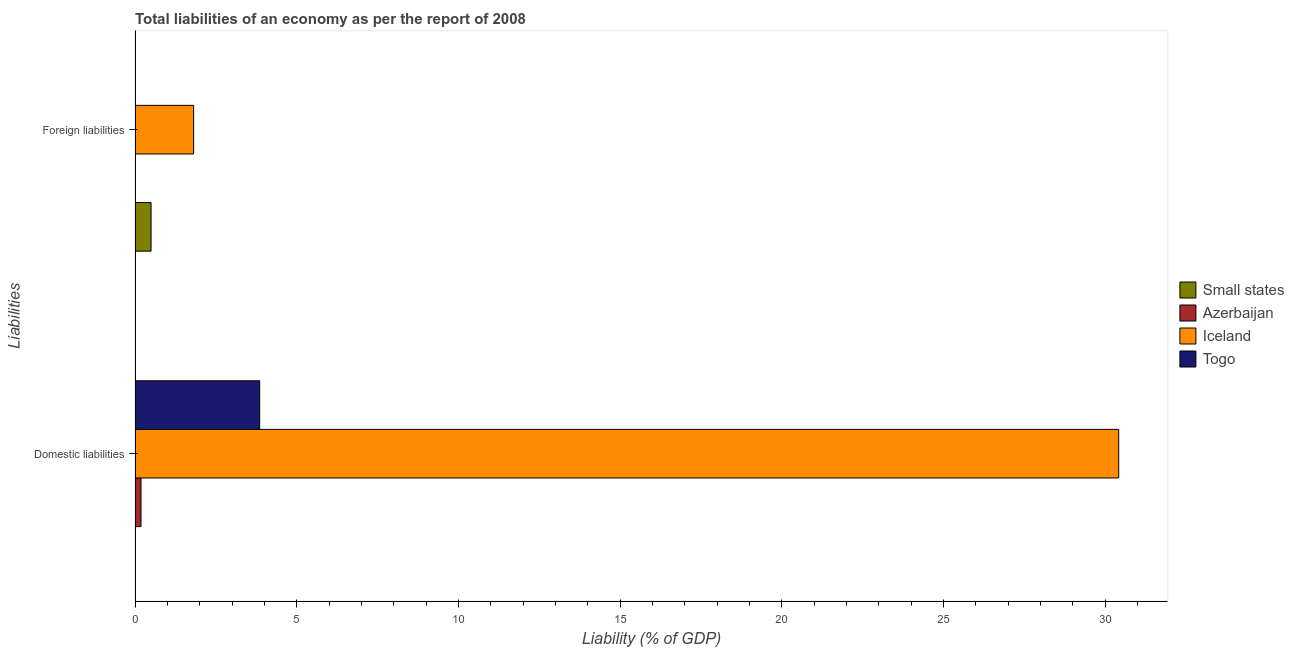How many bars are there on the 1st tick from the top?
Provide a short and direct response. 2. What is the label of the 1st group of bars from the top?
Give a very brief answer. Foreign liabilities. Across all countries, what is the maximum incurrence of foreign liabilities?
Provide a short and direct response. 1.81. In which country was the incurrence of foreign liabilities maximum?
Ensure brevity in your answer.  Iceland. What is the total incurrence of domestic liabilities in the graph?
Your answer should be very brief. 34.45. What is the difference between the incurrence of domestic liabilities in Iceland and that in Togo?
Your answer should be very brief. 26.56. What is the difference between the incurrence of foreign liabilities in Azerbaijan and the incurrence of domestic liabilities in Togo?
Provide a succinct answer. -3.85. What is the average incurrence of foreign liabilities per country?
Offer a very short reply. 0.58. What is the difference between the incurrence of foreign liabilities and incurrence of domestic liabilities in Iceland?
Your response must be concise. -28.6. In how many countries, is the incurrence of foreign liabilities greater than 22 %?
Provide a succinct answer. 0. What is the ratio of the incurrence of foreign liabilities in Iceland to that in Small states?
Keep it short and to the point. 3.66. In how many countries, is the incurrence of foreign liabilities greater than the average incurrence of foreign liabilities taken over all countries?
Make the answer very short. 1. How many bars are there?
Provide a succinct answer. 5. Are all the bars in the graph horizontal?
Your response must be concise. Yes. Does the graph contain grids?
Ensure brevity in your answer.  No. How many legend labels are there?
Give a very brief answer. 4. How are the legend labels stacked?
Offer a very short reply. Vertical. What is the title of the graph?
Give a very brief answer. Total liabilities of an economy as per the report of 2008. What is the label or title of the X-axis?
Make the answer very short. Liability (% of GDP). What is the label or title of the Y-axis?
Your response must be concise. Liabilities. What is the Liability (% of GDP) in Small states in Domestic liabilities?
Make the answer very short. 0. What is the Liability (% of GDP) of Azerbaijan in Domestic liabilities?
Your response must be concise. 0.18. What is the Liability (% of GDP) in Iceland in Domestic liabilities?
Provide a succinct answer. 30.41. What is the Liability (% of GDP) in Togo in Domestic liabilities?
Ensure brevity in your answer.  3.85. What is the Liability (% of GDP) in Small states in Foreign liabilities?
Offer a terse response. 0.5. What is the Liability (% of GDP) in Iceland in Foreign liabilities?
Make the answer very short. 1.81. What is the Liability (% of GDP) in Togo in Foreign liabilities?
Ensure brevity in your answer.  0. Across all Liabilities, what is the maximum Liability (% of GDP) of Small states?
Your answer should be compact. 0.5. Across all Liabilities, what is the maximum Liability (% of GDP) of Azerbaijan?
Provide a succinct answer. 0.18. Across all Liabilities, what is the maximum Liability (% of GDP) in Iceland?
Your response must be concise. 30.41. Across all Liabilities, what is the maximum Liability (% of GDP) in Togo?
Your response must be concise. 3.85. Across all Liabilities, what is the minimum Liability (% of GDP) in Iceland?
Your answer should be very brief. 1.81. Across all Liabilities, what is the minimum Liability (% of GDP) of Togo?
Offer a terse response. 0. What is the total Liability (% of GDP) in Small states in the graph?
Offer a very short reply. 0.5. What is the total Liability (% of GDP) in Azerbaijan in the graph?
Offer a terse response. 0.18. What is the total Liability (% of GDP) of Iceland in the graph?
Provide a succinct answer. 32.23. What is the total Liability (% of GDP) in Togo in the graph?
Give a very brief answer. 3.85. What is the difference between the Liability (% of GDP) of Iceland in Domestic liabilities and that in Foreign liabilities?
Make the answer very short. 28.6. What is the difference between the Liability (% of GDP) of Azerbaijan in Domestic liabilities and the Liability (% of GDP) of Iceland in Foreign liabilities?
Your answer should be very brief. -1.63. What is the average Liability (% of GDP) of Small states per Liabilities?
Make the answer very short. 0.25. What is the average Liability (% of GDP) of Azerbaijan per Liabilities?
Provide a succinct answer. 0.09. What is the average Liability (% of GDP) in Iceland per Liabilities?
Give a very brief answer. 16.11. What is the average Liability (% of GDP) of Togo per Liabilities?
Give a very brief answer. 1.93. What is the difference between the Liability (% of GDP) in Azerbaijan and Liability (% of GDP) in Iceland in Domestic liabilities?
Provide a succinct answer. -30.23. What is the difference between the Liability (% of GDP) of Azerbaijan and Liability (% of GDP) of Togo in Domestic liabilities?
Offer a terse response. -3.67. What is the difference between the Liability (% of GDP) in Iceland and Liability (% of GDP) in Togo in Domestic liabilities?
Provide a short and direct response. 26.56. What is the difference between the Liability (% of GDP) of Small states and Liability (% of GDP) of Iceland in Foreign liabilities?
Your answer should be very brief. -1.32. What is the ratio of the Liability (% of GDP) of Iceland in Domestic liabilities to that in Foreign liabilities?
Give a very brief answer. 16.8. What is the difference between the highest and the second highest Liability (% of GDP) of Iceland?
Give a very brief answer. 28.6. What is the difference between the highest and the lowest Liability (% of GDP) in Small states?
Make the answer very short. 0.5. What is the difference between the highest and the lowest Liability (% of GDP) in Azerbaijan?
Ensure brevity in your answer.  0.18. What is the difference between the highest and the lowest Liability (% of GDP) in Iceland?
Make the answer very short. 28.6. What is the difference between the highest and the lowest Liability (% of GDP) in Togo?
Ensure brevity in your answer.  3.85. 